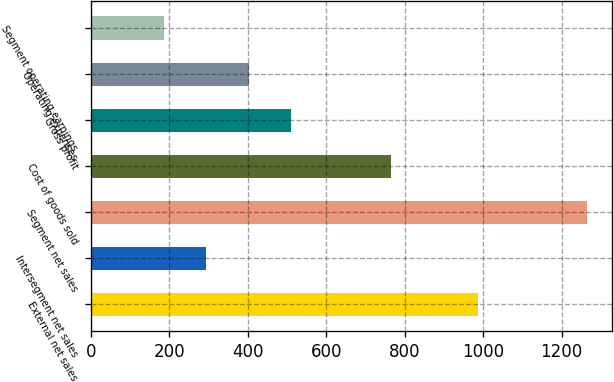Convert chart. <chart><loc_0><loc_0><loc_500><loc_500><bar_chart><fcel>External net sales<fcel>Intersegment net sales<fcel>Segment net sales<fcel>Cost of goods sold<fcel>Gross profit<fcel>Operating expenses<fcel>Segment operating earnings<nl><fcel>986.1<fcel>294.35<fcel>1265<fcel>766.4<fcel>510.05<fcel>402.2<fcel>186.5<nl></chart> 